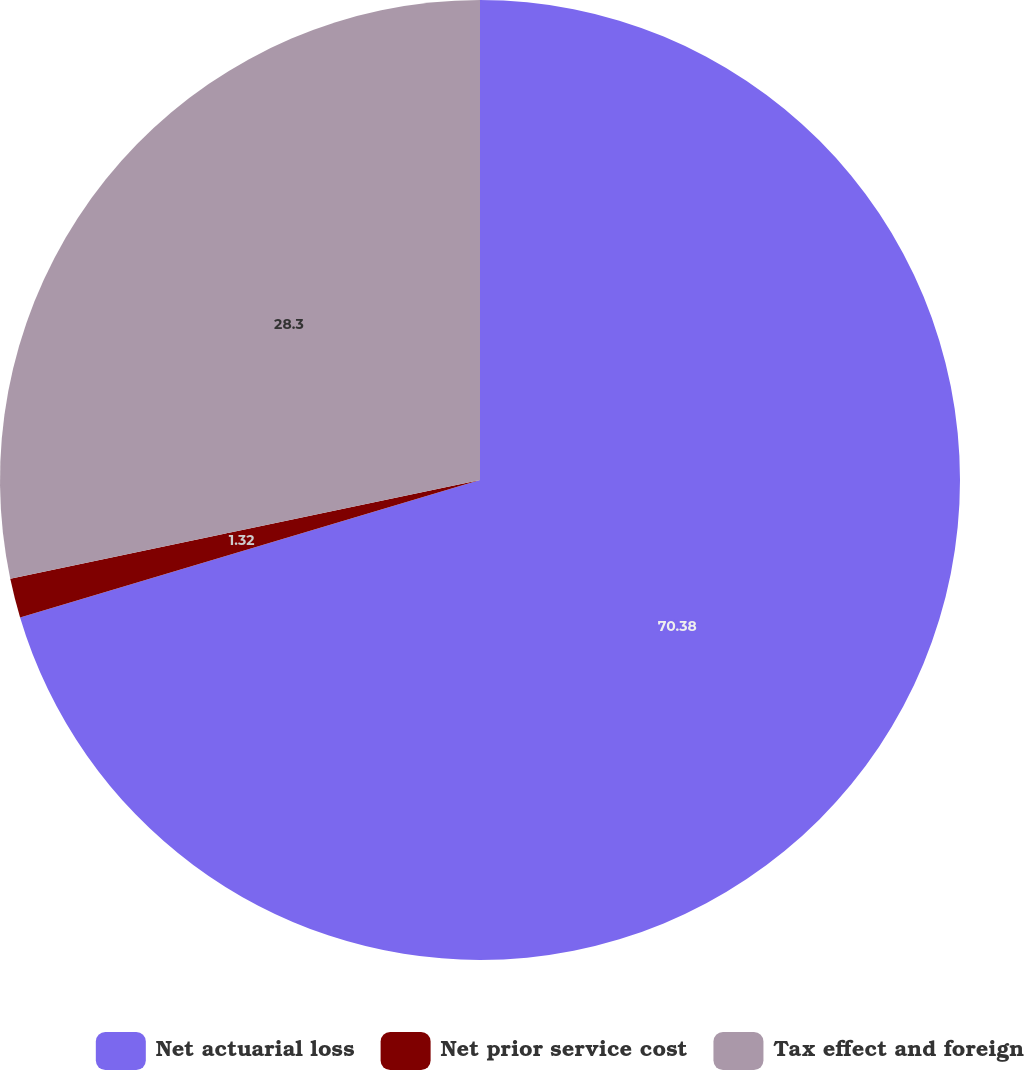<chart> <loc_0><loc_0><loc_500><loc_500><pie_chart><fcel>Net actuarial loss<fcel>Net prior service cost<fcel>Tax effect and foreign<nl><fcel>70.38%<fcel>1.32%<fcel>28.3%<nl></chart> 